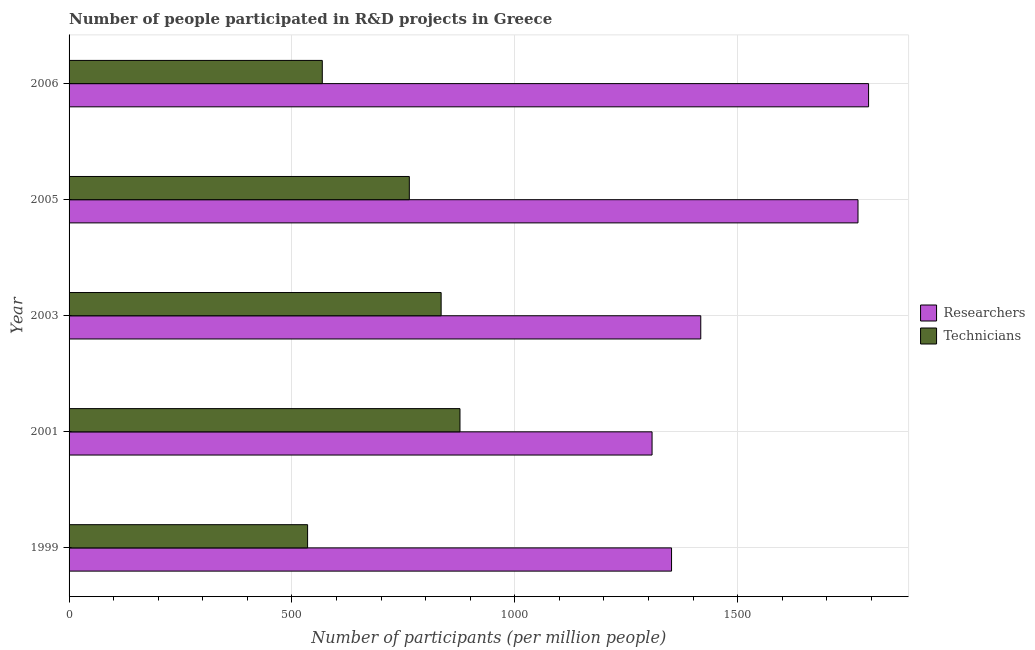Are the number of bars on each tick of the Y-axis equal?
Keep it short and to the point. Yes. What is the label of the 5th group of bars from the top?
Keep it short and to the point. 1999. What is the number of technicians in 2006?
Keep it short and to the point. 568.1. Across all years, what is the maximum number of technicians?
Offer a very short reply. 877.01. Across all years, what is the minimum number of technicians?
Provide a short and direct response. 535.14. In which year was the number of researchers maximum?
Your answer should be compact. 2006. In which year was the number of technicians minimum?
Ensure brevity in your answer.  1999. What is the total number of researchers in the graph?
Offer a very short reply. 7640.47. What is the difference between the number of researchers in 1999 and that in 2003?
Your response must be concise. -65.55. What is the difference between the number of technicians in 2001 and the number of researchers in 1999?
Ensure brevity in your answer.  -474.65. What is the average number of researchers per year?
Give a very brief answer. 1528.1. In the year 2005, what is the difference between the number of technicians and number of researchers?
Give a very brief answer. -1006.57. In how many years, is the number of researchers greater than 700 ?
Offer a very short reply. 5. What is the ratio of the number of researchers in 2001 to that in 2006?
Your answer should be very brief. 0.73. Is the number of researchers in 2005 less than that in 2006?
Provide a short and direct response. Yes. What is the difference between the highest and the second highest number of researchers?
Offer a very short reply. 23.75. What is the difference between the highest and the lowest number of researchers?
Ensure brevity in your answer.  485.76. Is the sum of the number of researchers in 2003 and 2006 greater than the maximum number of technicians across all years?
Provide a short and direct response. Yes. What does the 2nd bar from the top in 2001 represents?
Give a very brief answer. Researchers. What does the 1st bar from the bottom in 2003 represents?
Provide a succinct answer. Researchers. How many years are there in the graph?
Provide a short and direct response. 5. What is the difference between two consecutive major ticks on the X-axis?
Your answer should be compact. 500. Where does the legend appear in the graph?
Your response must be concise. Center right. How many legend labels are there?
Your answer should be very brief. 2. What is the title of the graph?
Ensure brevity in your answer.  Number of people participated in R&D projects in Greece. Does "Fertility rate" appear as one of the legend labels in the graph?
Your answer should be compact. No. What is the label or title of the X-axis?
Keep it short and to the point. Number of participants (per million people). What is the label or title of the Y-axis?
Provide a succinct answer. Year. What is the Number of participants (per million people) in Researchers in 1999?
Keep it short and to the point. 1351.66. What is the Number of participants (per million people) of Technicians in 1999?
Offer a terse response. 535.14. What is the Number of participants (per million people) of Researchers in 2001?
Provide a short and direct response. 1307.94. What is the Number of participants (per million people) in Technicians in 2001?
Provide a succinct answer. 877.01. What is the Number of participants (per million people) of Researchers in 2003?
Your answer should be compact. 1417.21. What is the Number of participants (per million people) of Technicians in 2003?
Offer a very short reply. 834.74. What is the Number of participants (per million people) in Researchers in 2005?
Provide a short and direct response. 1769.95. What is the Number of participants (per million people) of Technicians in 2005?
Make the answer very short. 763.38. What is the Number of participants (per million people) of Researchers in 2006?
Your answer should be compact. 1793.7. What is the Number of participants (per million people) of Technicians in 2006?
Provide a succinct answer. 568.1. Across all years, what is the maximum Number of participants (per million people) of Researchers?
Ensure brevity in your answer.  1793.7. Across all years, what is the maximum Number of participants (per million people) of Technicians?
Keep it short and to the point. 877.01. Across all years, what is the minimum Number of participants (per million people) of Researchers?
Make the answer very short. 1307.94. Across all years, what is the minimum Number of participants (per million people) of Technicians?
Your answer should be very brief. 535.14. What is the total Number of participants (per million people) of Researchers in the graph?
Provide a succinct answer. 7640.47. What is the total Number of participants (per million people) in Technicians in the graph?
Offer a very short reply. 3578.37. What is the difference between the Number of participants (per million people) of Researchers in 1999 and that in 2001?
Keep it short and to the point. 43.72. What is the difference between the Number of participants (per million people) in Technicians in 1999 and that in 2001?
Offer a terse response. -341.87. What is the difference between the Number of participants (per million people) of Researchers in 1999 and that in 2003?
Offer a terse response. -65.55. What is the difference between the Number of participants (per million people) of Technicians in 1999 and that in 2003?
Keep it short and to the point. -299.6. What is the difference between the Number of participants (per million people) of Researchers in 1999 and that in 2005?
Your answer should be very brief. -418.29. What is the difference between the Number of participants (per million people) of Technicians in 1999 and that in 2005?
Your answer should be very brief. -228.24. What is the difference between the Number of participants (per million people) of Researchers in 1999 and that in 2006?
Keep it short and to the point. -442.04. What is the difference between the Number of participants (per million people) of Technicians in 1999 and that in 2006?
Provide a short and direct response. -32.96. What is the difference between the Number of participants (per million people) in Researchers in 2001 and that in 2003?
Offer a terse response. -109.27. What is the difference between the Number of participants (per million people) in Technicians in 2001 and that in 2003?
Offer a terse response. 42.27. What is the difference between the Number of participants (per million people) in Researchers in 2001 and that in 2005?
Your answer should be compact. -462.01. What is the difference between the Number of participants (per million people) in Technicians in 2001 and that in 2005?
Provide a succinct answer. 113.63. What is the difference between the Number of participants (per million people) in Researchers in 2001 and that in 2006?
Offer a very short reply. -485.76. What is the difference between the Number of participants (per million people) of Technicians in 2001 and that in 2006?
Give a very brief answer. 308.91. What is the difference between the Number of participants (per million people) in Researchers in 2003 and that in 2005?
Give a very brief answer. -352.74. What is the difference between the Number of participants (per million people) of Technicians in 2003 and that in 2005?
Keep it short and to the point. 71.35. What is the difference between the Number of participants (per million people) of Researchers in 2003 and that in 2006?
Your answer should be compact. -376.49. What is the difference between the Number of participants (per million people) in Technicians in 2003 and that in 2006?
Make the answer very short. 266.64. What is the difference between the Number of participants (per million people) of Researchers in 2005 and that in 2006?
Keep it short and to the point. -23.75. What is the difference between the Number of participants (per million people) of Technicians in 2005 and that in 2006?
Your answer should be compact. 195.28. What is the difference between the Number of participants (per million people) of Researchers in 1999 and the Number of participants (per million people) of Technicians in 2001?
Your answer should be very brief. 474.65. What is the difference between the Number of participants (per million people) in Researchers in 1999 and the Number of participants (per million people) in Technicians in 2003?
Your answer should be very brief. 516.92. What is the difference between the Number of participants (per million people) in Researchers in 1999 and the Number of participants (per million people) in Technicians in 2005?
Offer a terse response. 588.28. What is the difference between the Number of participants (per million people) in Researchers in 1999 and the Number of participants (per million people) in Technicians in 2006?
Offer a terse response. 783.56. What is the difference between the Number of participants (per million people) of Researchers in 2001 and the Number of participants (per million people) of Technicians in 2003?
Make the answer very short. 473.21. What is the difference between the Number of participants (per million people) of Researchers in 2001 and the Number of participants (per million people) of Technicians in 2005?
Your answer should be compact. 544.56. What is the difference between the Number of participants (per million people) in Researchers in 2001 and the Number of participants (per million people) in Technicians in 2006?
Offer a terse response. 739.84. What is the difference between the Number of participants (per million people) of Researchers in 2003 and the Number of participants (per million people) of Technicians in 2005?
Keep it short and to the point. 653.83. What is the difference between the Number of participants (per million people) in Researchers in 2003 and the Number of participants (per million people) in Technicians in 2006?
Ensure brevity in your answer.  849.11. What is the difference between the Number of participants (per million people) in Researchers in 2005 and the Number of participants (per million people) in Technicians in 2006?
Provide a short and direct response. 1201.85. What is the average Number of participants (per million people) in Researchers per year?
Keep it short and to the point. 1528.09. What is the average Number of participants (per million people) of Technicians per year?
Make the answer very short. 715.67. In the year 1999, what is the difference between the Number of participants (per million people) in Researchers and Number of participants (per million people) in Technicians?
Provide a succinct answer. 816.52. In the year 2001, what is the difference between the Number of participants (per million people) in Researchers and Number of participants (per million people) in Technicians?
Your answer should be compact. 430.93. In the year 2003, what is the difference between the Number of participants (per million people) in Researchers and Number of participants (per million people) in Technicians?
Your answer should be very brief. 582.47. In the year 2005, what is the difference between the Number of participants (per million people) of Researchers and Number of participants (per million people) of Technicians?
Give a very brief answer. 1006.57. In the year 2006, what is the difference between the Number of participants (per million people) in Researchers and Number of participants (per million people) in Technicians?
Your answer should be compact. 1225.6. What is the ratio of the Number of participants (per million people) of Researchers in 1999 to that in 2001?
Give a very brief answer. 1.03. What is the ratio of the Number of participants (per million people) in Technicians in 1999 to that in 2001?
Offer a very short reply. 0.61. What is the ratio of the Number of participants (per million people) of Researchers in 1999 to that in 2003?
Your answer should be very brief. 0.95. What is the ratio of the Number of participants (per million people) of Technicians in 1999 to that in 2003?
Keep it short and to the point. 0.64. What is the ratio of the Number of participants (per million people) of Researchers in 1999 to that in 2005?
Your answer should be compact. 0.76. What is the ratio of the Number of participants (per million people) of Technicians in 1999 to that in 2005?
Keep it short and to the point. 0.7. What is the ratio of the Number of participants (per million people) in Researchers in 1999 to that in 2006?
Give a very brief answer. 0.75. What is the ratio of the Number of participants (per million people) of Technicians in 1999 to that in 2006?
Ensure brevity in your answer.  0.94. What is the ratio of the Number of participants (per million people) in Researchers in 2001 to that in 2003?
Offer a very short reply. 0.92. What is the ratio of the Number of participants (per million people) in Technicians in 2001 to that in 2003?
Your response must be concise. 1.05. What is the ratio of the Number of participants (per million people) of Researchers in 2001 to that in 2005?
Your answer should be compact. 0.74. What is the ratio of the Number of participants (per million people) in Technicians in 2001 to that in 2005?
Offer a very short reply. 1.15. What is the ratio of the Number of participants (per million people) of Researchers in 2001 to that in 2006?
Give a very brief answer. 0.73. What is the ratio of the Number of participants (per million people) in Technicians in 2001 to that in 2006?
Provide a short and direct response. 1.54. What is the ratio of the Number of participants (per million people) in Researchers in 2003 to that in 2005?
Your answer should be very brief. 0.8. What is the ratio of the Number of participants (per million people) in Technicians in 2003 to that in 2005?
Your answer should be compact. 1.09. What is the ratio of the Number of participants (per million people) of Researchers in 2003 to that in 2006?
Keep it short and to the point. 0.79. What is the ratio of the Number of participants (per million people) of Technicians in 2003 to that in 2006?
Provide a short and direct response. 1.47. What is the ratio of the Number of participants (per million people) in Technicians in 2005 to that in 2006?
Offer a terse response. 1.34. What is the difference between the highest and the second highest Number of participants (per million people) of Researchers?
Your response must be concise. 23.75. What is the difference between the highest and the second highest Number of participants (per million people) in Technicians?
Your answer should be very brief. 42.27. What is the difference between the highest and the lowest Number of participants (per million people) in Researchers?
Make the answer very short. 485.76. What is the difference between the highest and the lowest Number of participants (per million people) in Technicians?
Offer a very short reply. 341.87. 